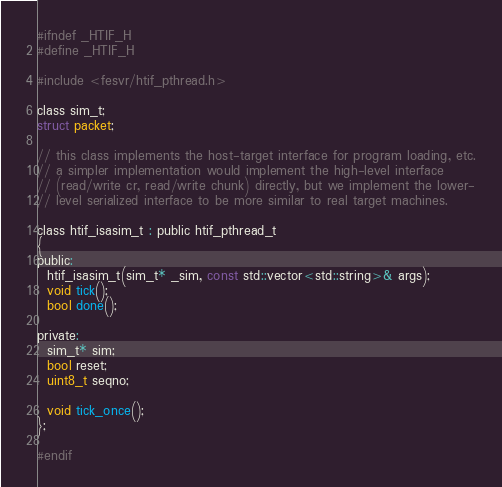Convert code to text. <code><loc_0><loc_0><loc_500><loc_500><_C_>#ifndef _HTIF_H
#define _HTIF_H

#include <fesvr/htif_pthread.h>

class sim_t;
struct packet;

// this class implements the host-target interface for program loading, etc.
// a simpler implementation would implement the high-level interface
// (read/write cr, read/write chunk) directly, but we implement the lower-
// level serialized interface to be more similar to real target machines.

class htif_isasim_t : public htif_pthread_t
{
public:
  htif_isasim_t(sim_t* _sim, const std::vector<std::string>& args);
  void tick();
  bool done();

private:
  sim_t* sim;
  bool reset;
  uint8_t seqno;

  void tick_once();
};

#endif
</code> 